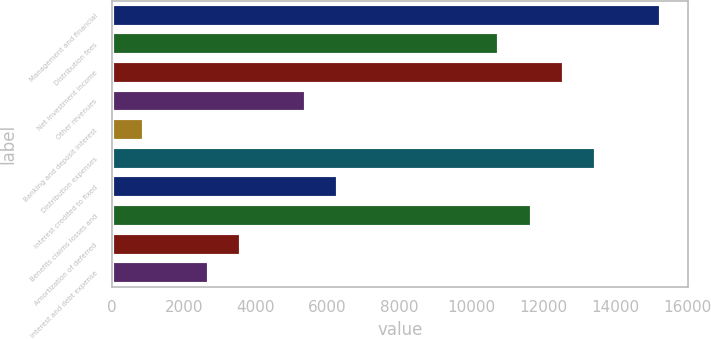Convert chart. <chart><loc_0><loc_0><loc_500><loc_500><bar_chart><fcel>Management and financial<fcel>Distribution fees<fcel>Net investment income<fcel>Other revenues<fcel>Banking and deposit interest<fcel>Distribution expenses<fcel>Interest credited to fixed<fcel>Benefits claims losses and<fcel>Amortization of deferred<fcel>Interest and debt expense<nl><fcel>15262.9<fcel>10774.4<fcel>12569.8<fcel>5388.2<fcel>899.7<fcel>13467.5<fcel>6285.9<fcel>11672.1<fcel>3592.8<fcel>2695.1<nl></chart> 